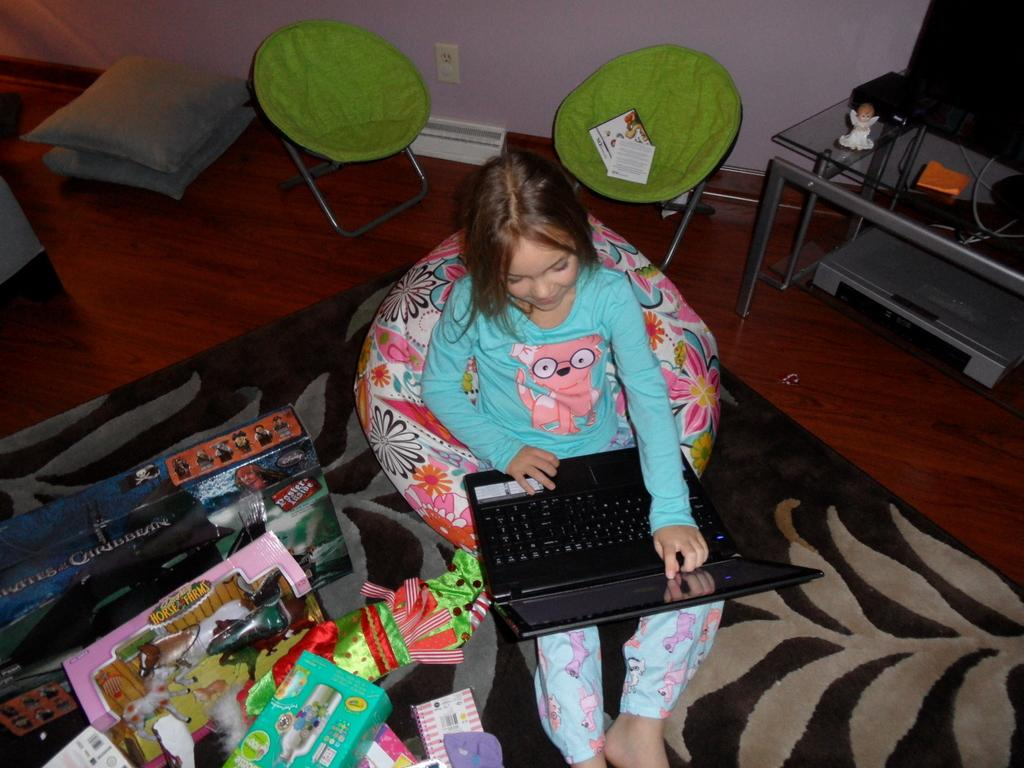Where was the photo taken? The photo was taken inside a room. What is the girl doing in the photo? The girl is sitting on a chair and holding a laptop. What else can be seen near the girl? There are toys beside the girl and a TV on a table behind her. How many chairs are in the room? There are two chairs in the room. What type of seating is available in the room? There are cushions in the room. What color is the rabbit's sweater in the photo? There is no rabbit or sweater present in the photo. Can you tell me how the girl is helping the rabbit with the laptop? There is no rabbit or indication of the girl helping anyone in the photo. 